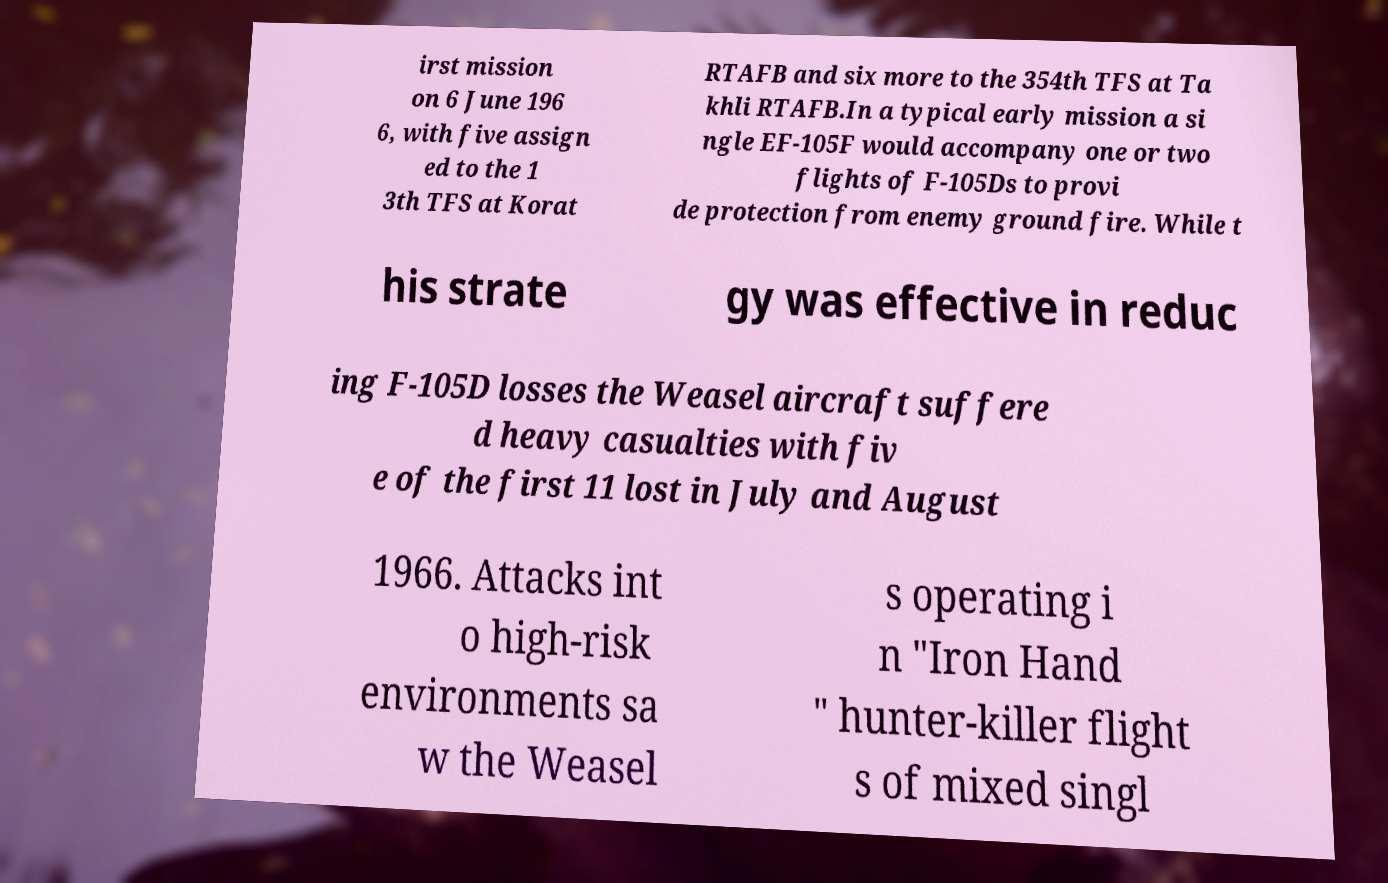Please identify and transcribe the text found in this image. irst mission on 6 June 196 6, with five assign ed to the 1 3th TFS at Korat RTAFB and six more to the 354th TFS at Ta khli RTAFB.In a typical early mission a si ngle EF-105F would accompany one or two flights of F-105Ds to provi de protection from enemy ground fire. While t his strate gy was effective in reduc ing F-105D losses the Weasel aircraft suffere d heavy casualties with fiv e of the first 11 lost in July and August 1966. Attacks int o high-risk environments sa w the Weasel s operating i n "Iron Hand " hunter-killer flight s of mixed singl 